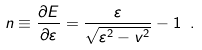Convert formula to latex. <formula><loc_0><loc_0><loc_500><loc_500>n \equiv \frac { \partial E } { \partial \varepsilon } = \frac { \varepsilon } { \sqrt { \varepsilon ^ { 2 } - v ^ { 2 } } } - 1 \ .</formula> 